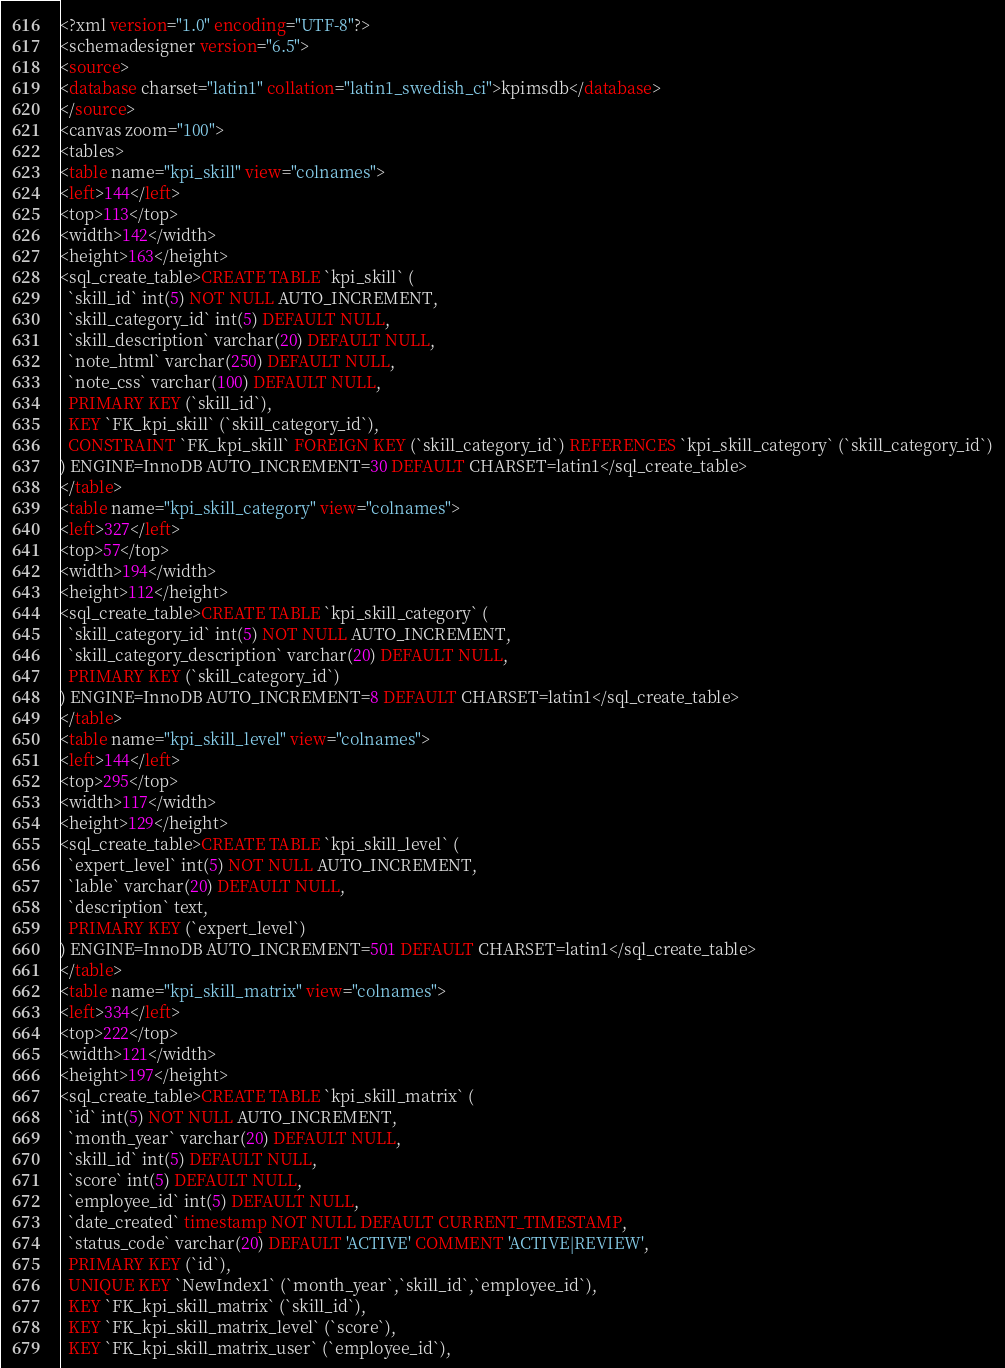<code> <loc_0><loc_0><loc_500><loc_500><_SQL_><?xml version="1.0" encoding="UTF-8"?>
<schemadesigner version="6.5">
<source>
<database charset="latin1" collation="latin1_swedish_ci">kpimsdb</database>
</source>
<canvas zoom="100">
<tables>
<table name="kpi_skill" view="colnames">
<left>144</left>
<top>113</top>
<width>142</width>
<height>163</height>
<sql_create_table>CREATE TABLE `kpi_skill` (
  `skill_id` int(5) NOT NULL AUTO_INCREMENT,
  `skill_category_id` int(5) DEFAULT NULL,
  `skill_description` varchar(20) DEFAULT NULL,
  `note_html` varchar(250) DEFAULT NULL,
  `note_css` varchar(100) DEFAULT NULL,
  PRIMARY KEY (`skill_id`),
  KEY `FK_kpi_skill` (`skill_category_id`),
  CONSTRAINT `FK_kpi_skill` FOREIGN KEY (`skill_category_id`) REFERENCES `kpi_skill_category` (`skill_category_id`)
) ENGINE=InnoDB AUTO_INCREMENT=30 DEFAULT CHARSET=latin1</sql_create_table>
</table>
<table name="kpi_skill_category" view="colnames">
<left>327</left>
<top>57</top>
<width>194</width>
<height>112</height>
<sql_create_table>CREATE TABLE `kpi_skill_category` (
  `skill_category_id` int(5) NOT NULL AUTO_INCREMENT,
  `skill_category_description` varchar(20) DEFAULT NULL,
  PRIMARY KEY (`skill_category_id`)
) ENGINE=InnoDB AUTO_INCREMENT=8 DEFAULT CHARSET=latin1</sql_create_table>
</table>
<table name="kpi_skill_level" view="colnames">
<left>144</left>
<top>295</top>
<width>117</width>
<height>129</height>
<sql_create_table>CREATE TABLE `kpi_skill_level` (
  `expert_level` int(5) NOT NULL AUTO_INCREMENT,
  `lable` varchar(20) DEFAULT NULL,
  `description` text,
  PRIMARY KEY (`expert_level`)
) ENGINE=InnoDB AUTO_INCREMENT=501 DEFAULT CHARSET=latin1</sql_create_table>
</table>
<table name="kpi_skill_matrix" view="colnames">
<left>334</left>
<top>222</top>
<width>121</width>
<height>197</height>
<sql_create_table>CREATE TABLE `kpi_skill_matrix` (
  `id` int(5) NOT NULL AUTO_INCREMENT,
  `month_year` varchar(20) DEFAULT NULL,
  `skill_id` int(5) DEFAULT NULL,
  `score` int(5) DEFAULT NULL,
  `employee_id` int(5) DEFAULT NULL,
  `date_created` timestamp NOT NULL DEFAULT CURRENT_TIMESTAMP,
  `status_code` varchar(20) DEFAULT 'ACTIVE' COMMENT 'ACTIVE|REVIEW',
  PRIMARY KEY (`id`),
  UNIQUE KEY `NewIndex1` (`month_year`,`skill_id`,`employee_id`),
  KEY `FK_kpi_skill_matrix` (`skill_id`),
  KEY `FK_kpi_skill_matrix_level` (`score`),
  KEY `FK_kpi_skill_matrix_user` (`employee_id`),</code> 